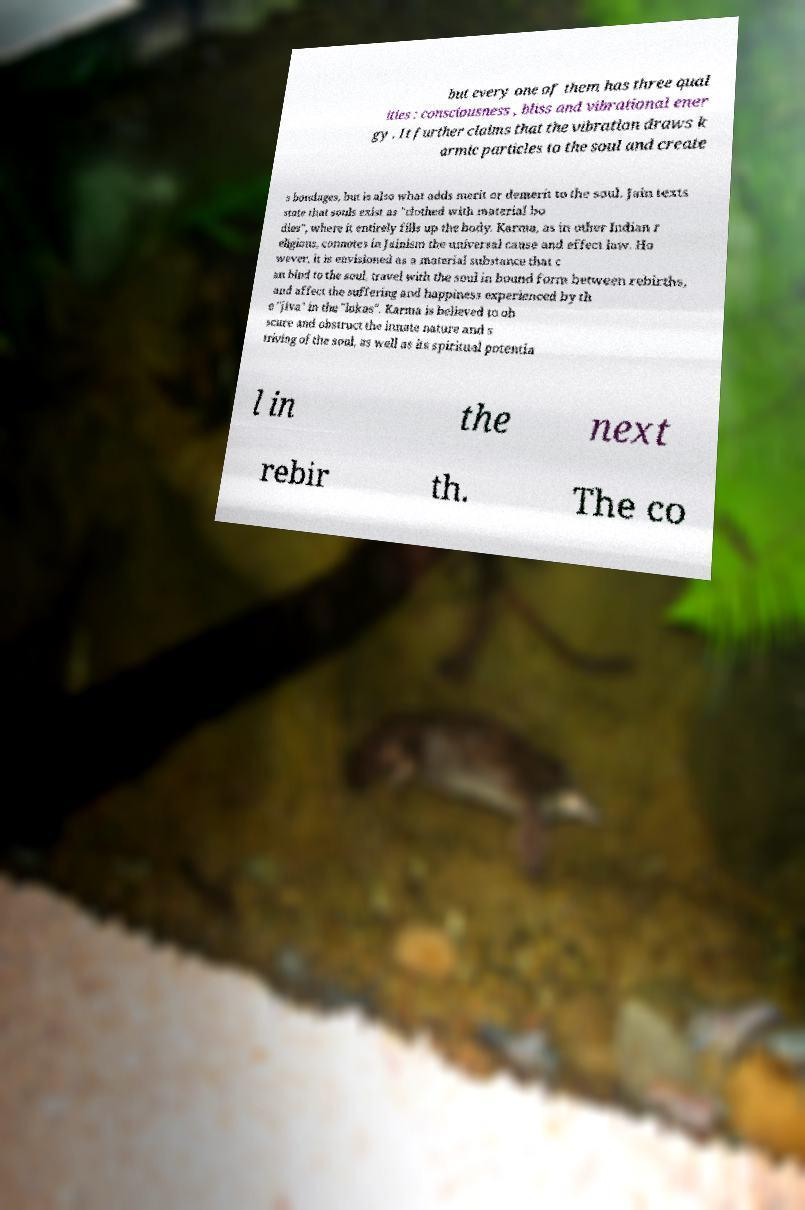I need the written content from this picture converted into text. Can you do that? but every one of them has three qual ities : consciousness , bliss and vibrational ener gy . It further claims that the vibration draws k armic particles to the soul and create s bondages, but is also what adds merit or demerit to the soul. Jain texts state that souls exist as "clothed with material bo dies", where it entirely fills up the body. Karma, as in other Indian r eligions, connotes in Jainism the universal cause and effect law. Ho wever, it is envisioned as a material substance that c an bind to the soul, travel with the soul in bound form between rebirths, and affect the suffering and happiness experienced by th e "jiva" in the "lokas". Karma is believed to ob scure and obstruct the innate nature and s triving of the soul, as well as its spiritual potentia l in the next rebir th. The co 